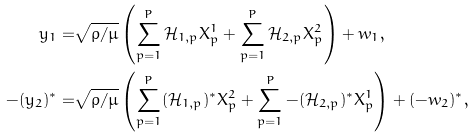Convert formula to latex. <formula><loc_0><loc_0><loc_500><loc_500>y _ { 1 } = & \sqrt { \rho / \mu } \left ( \sum ^ { P } _ { p = 1 } \mathcal { H } _ { 1 , p } X ^ { 1 } _ { p } + \sum ^ { P } _ { p = 1 } \mathcal { H } _ { 2 , p } X ^ { 2 } _ { p } \right ) + w _ { 1 } , \\ - ( y _ { 2 } ) ^ { \ast } = & \sqrt { \rho / \mu } \left ( \sum ^ { P } _ { p = 1 } ( \mathcal { H } _ { 1 , p } ) ^ { \ast } X ^ { 2 } _ { p } + \sum ^ { P } _ { p = 1 } - ( \mathcal { H } _ { 2 , p } ) ^ { \ast } X ^ { 1 } _ { p } \right ) + ( - w _ { 2 } ) ^ { \ast } ,</formula> 